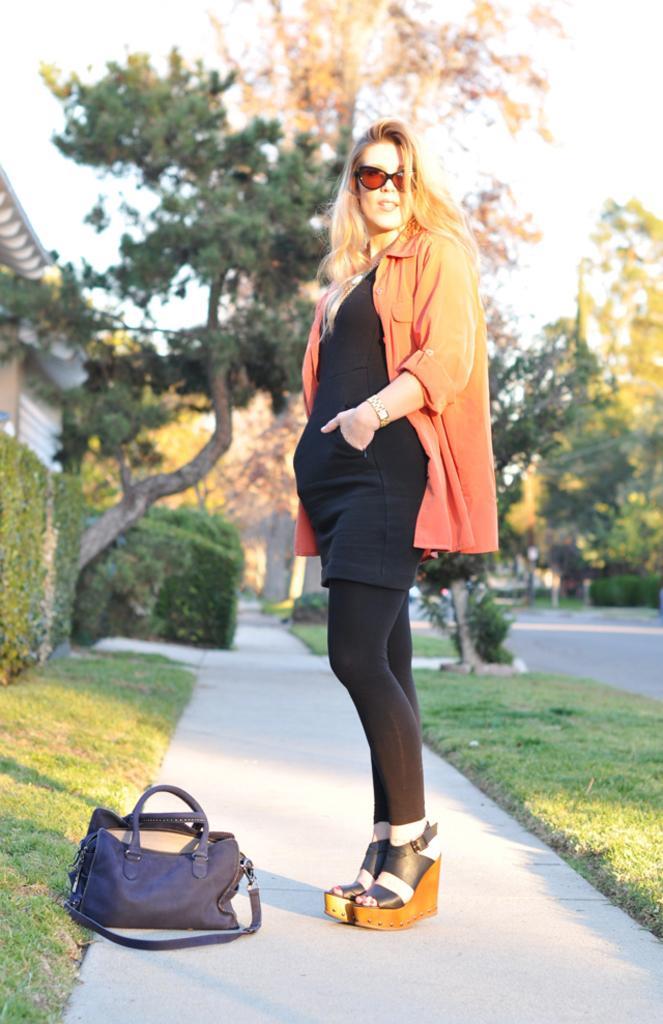Can you describe this image briefly? This is the picture taken in the outdoor. It is sunny. The women in orange shirt standing on a path on the left side of the women there is a black color bag. Background of the woman is a tree and sky. 